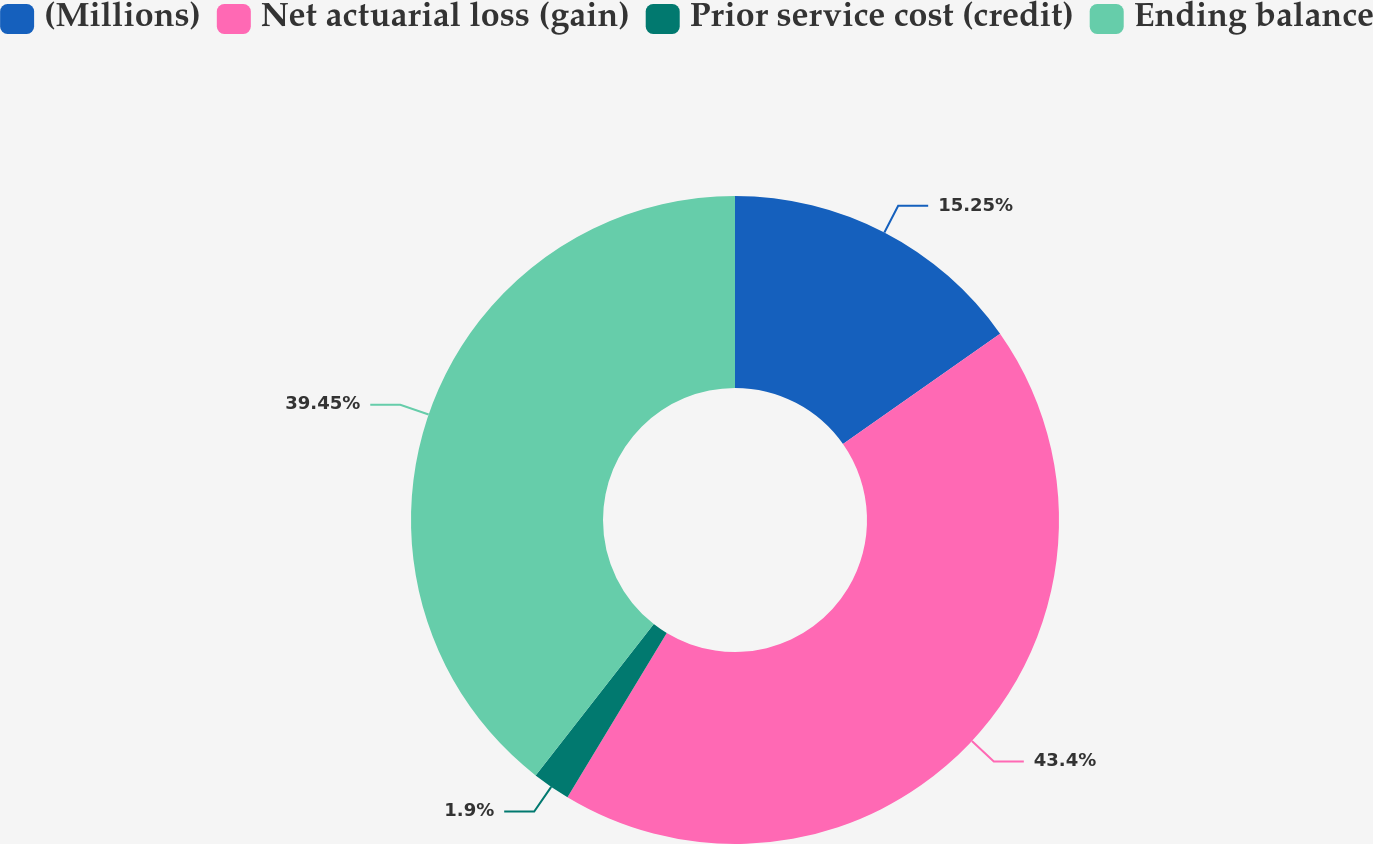Convert chart. <chart><loc_0><loc_0><loc_500><loc_500><pie_chart><fcel>(Millions)<fcel>Net actuarial loss (gain)<fcel>Prior service cost (credit)<fcel>Ending balance<nl><fcel>15.25%<fcel>43.4%<fcel>1.9%<fcel>39.45%<nl></chart> 